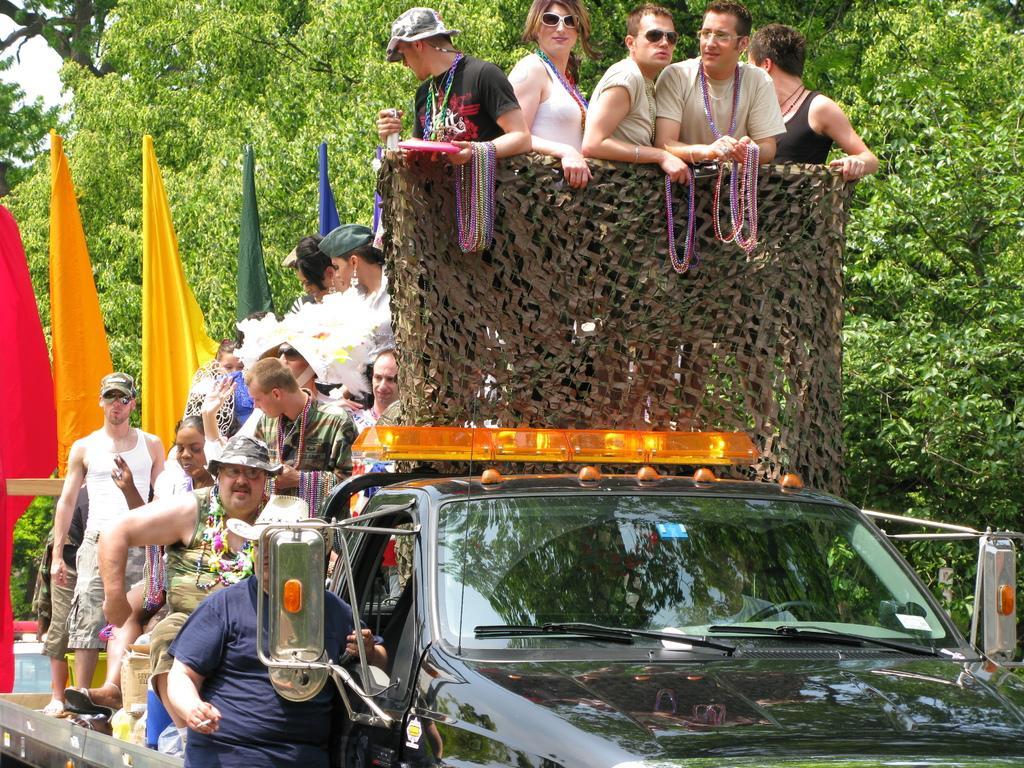How would you summarize this image in a sentence or two? In this image I can see the group of people standing on the vehicle. These people are wearing the different color dresses and few people with the hats. In the back I can see the colorful flags. I can also see manatees and the sky in the back. 